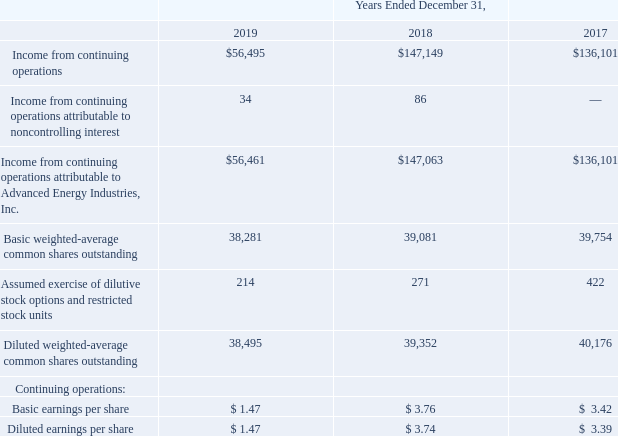ADVANCED ENERGY INDUSTRIES, INC. NOTES TO CONSOLIDATED FINANCIAL STATEMENTS – (continued) (in thousands, except per share amounts)
NOTE 6. EARNINGS PER SHARE
Basic earnings per share (“EPS”) is computed by dividing income available to common stockholders by the weighted-average number of common shares outstanding during the period. The computation of diluted EPS is similar to the computation of basic EPS except that the denominator is increased to include the number of additional common shares that would have been outstanding (using the if-converted and treasury stock methods), if our outstanding stock options and restricted stock units had been converted to common shares, and if such assumed conversion is dilutive.
The following is a reconciliation of the weighted-average shares outstanding used in the calculation of basic and diluted earnings per share for the years ended December 31, 2019, 2018 and 2017:
How was Basic earnings per share (“EPS”) computed by the company? By dividing income available to common stockholders by the weighted-average number of common shares outstanding during the period. What was the Income from continuing operations attributable to Advanced Energy Industries, Inc. in 2017?
Answer scale should be: thousand. $136,101. What was the Basic weighted-average common shares outstanding in 2019?
Answer scale should be: thousand. 38,281. What was the change in Assumed exercise of dilutive stock options and restricted stock units between 2018 and 2019?
Answer scale should be: thousand. 214-271
Answer: -57. What was the change in Diluted weighted-average common shares outstanding between 2018 and 2019?
Answer scale should be: thousand. 38,495-39,352
Answer: -857. What was the percentage change in Income from continuing operations between 2017 and 2018?
Answer scale should be: percent. ($147,149-$136,101)/136,101
Answer: 8.12. 